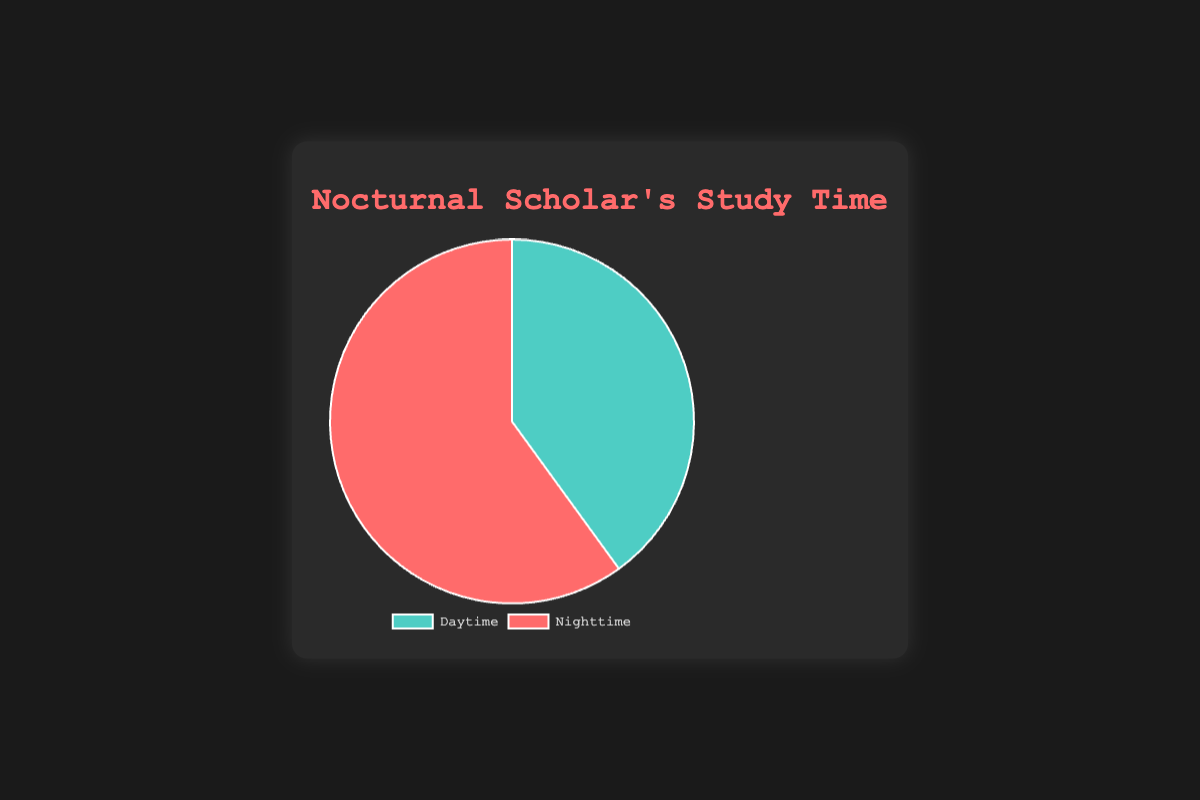What's the total number of hours spent studying in a week? Sum the hours spent during the daytime and nighttime to get the total. Daytime hours = 28, Nighttime hours = 42. Total = 28 + 42 = 70 hours
Answer: 70 hours Which time period has a higher percentage of study time? Compare the percentages for daytime and nighttime. Daytime: 40%, Nighttime: 60%. Nighttime has a higher percentage.
Answer: Nighttime What's the percentage difference between daytime and nighttime study hours? Subtract the daytime percentage from the nighttime percentage. Nighttime: 60%, Daytime: 40%. Difference = 60% - 40% = 20%
Answer: 20% What color represents nighttime in the pie chart? Observe the colors in the pie chart for the labels. Nighttime is represented by red
Answer: red By how many hours does your nighttime study exceed your daytime study? Subtract the daytime hours from the nighttime hours. Nighttime: 42 hours, Daytime: 28 hours. Difference = 42 - 28 = 14 hours
Answer: 14 hours If the total study time in a week was divided equally between day and night, how many hours would be spent studying during each period? Divide the total hours by 2 to find the equal distribution. Total hours = 70. Equal hours = 70 / 2 = 35
Answer: 35 hours What is the ratio of daytime to nighttime study hours? Divide the daytime hours by the nighttime hours to get the ratio. Daytime: 28, Nighttime: 42. Ratio = 28 / 42 = 2:3
Answer: 2:3 What percentage of your study time is spent at night? Directly refer to the percentage for nighttime study in the pie chart. Nighttime is 60%
Answer: 60% 